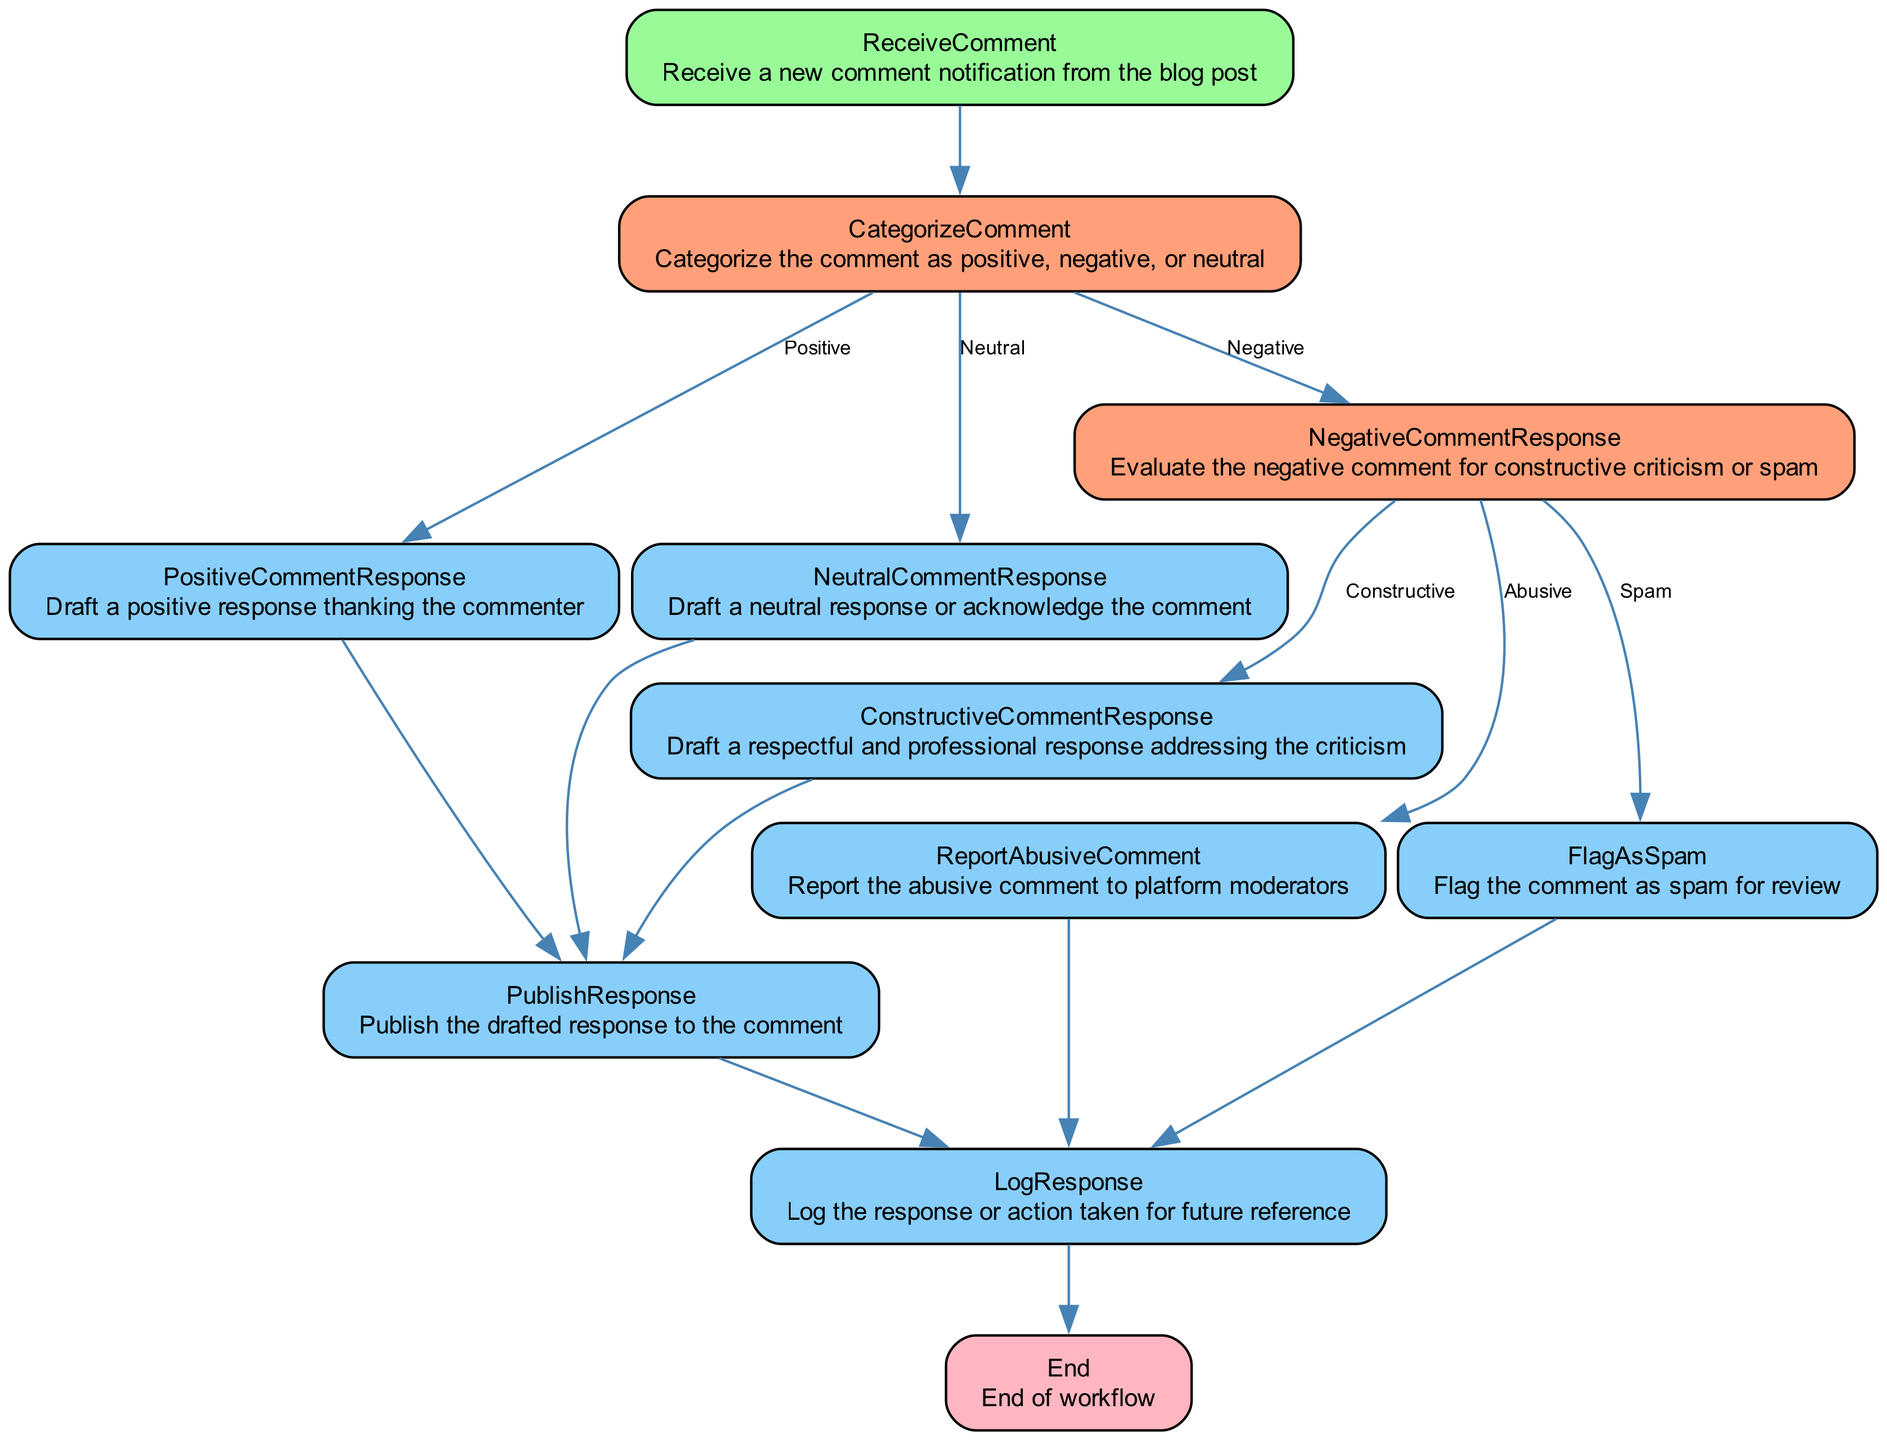What is the first step in the workflow? The first step in the workflow is to receive a new comment notification from the blog post. This is indicated by the node labeled 'ReceiveComment', which is the starting point of the flowchart.
Answer: ReceiveComment How many different categories can comments be classified into? Comments can be categorized into three types: positive, negative, and neutral. This is represented in the 'CategorizeComment' node, where these three options are indicated as possible next steps.
Answer: Three What happens to a neutral comment? For a neutral comment, the next step is to draft a neutral response or acknowledge the comment. This is specified in the 'NeutralCommentResponse' node, which follows from the 'CategorizeComment' node's neutral branch.
Answer: NeutralCommentResponse What are the possible next steps after a negative comment is evaluated? After evaluating a negative comment, there are three possible next steps: drafting a constructive comment response, flagging the comment as spam, or reporting the comment as abusive. These three options are displayed as branches from the 'NegativeCommentResponse' node.
Answer: ConstructiveCommentResponse, FlagAsSpam, ReportAbusiveComment What is the last step in the workflow? The last step in the workflow is to log the response or action taken for future reference. This task is outlined in the 'LogResponse' node, indicating that all actions culminate in logging before ending the workflow.
Answer: LogResponse How many total unique nodes are there in the workflow? The diagram provided includes ten unique nodes, representing different stages or actions in the comment moderation workflow. By counting each separate function or action described in the diagram, we arrive at this total.
Answer: Ten What action is taken for spam comments? Spam comments are flagged for review, which is indicated by the 'FlagAsSpam' node that is reached after evaluating a negative comment in the workflow.
Answer: FlagAsSpam What is drafted in response to a positive comment? A positive response is drafted thanking the commenter, which is described in the 'PositiveCommentResponse' node following the categorization of the comment as positive.
Answer: PositiveCommentResponse 